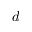<formula> <loc_0><loc_0><loc_500><loc_500>d</formula> 